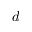<formula> <loc_0><loc_0><loc_500><loc_500>d</formula> 